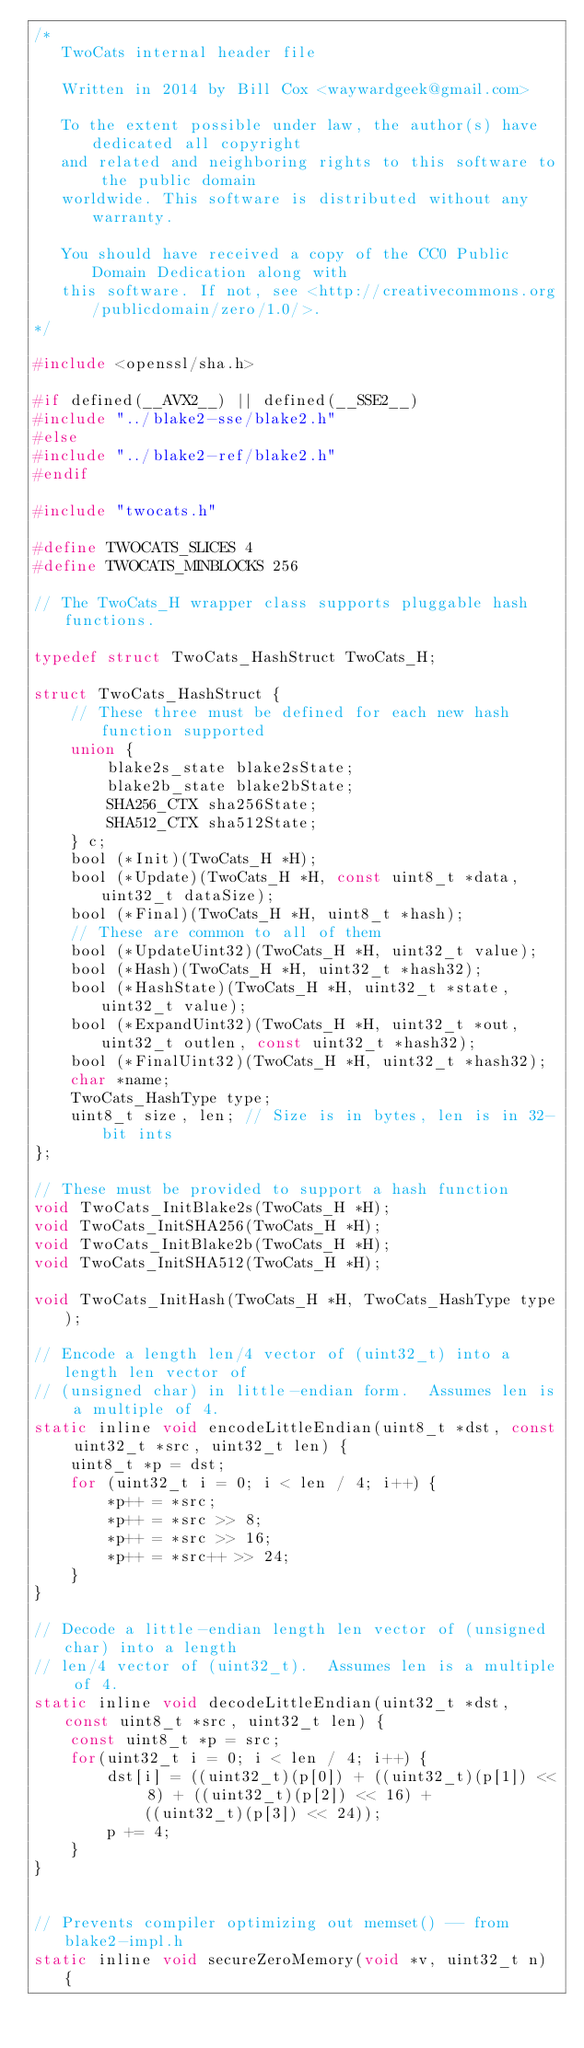<code> <loc_0><loc_0><loc_500><loc_500><_C_>/*
   TwoCats internal header file

   Written in 2014 by Bill Cox <waywardgeek@gmail.com>

   To the extent possible under law, the author(s) have dedicated all copyright
   and related and neighboring rights to this software to the public domain
   worldwide. This software is distributed without any warranty.

   You should have received a copy of the CC0 Public Domain Dedication along with
   this software. If not, see <http://creativecommons.org/publicdomain/zero/1.0/>.
*/

#include <openssl/sha.h>

#if defined(__AVX2__) || defined(__SSE2__)
#include "../blake2-sse/blake2.h"
#else
#include "../blake2-ref/blake2.h"
#endif

#include "twocats.h"

#define TWOCATS_SLICES 4
#define TWOCATS_MINBLOCKS 256

// The TwoCats_H wrapper class supports pluggable hash functions.

typedef struct TwoCats_HashStruct TwoCats_H;

struct TwoCats_HashStruct {
    // These three must be defined for each new hash function supported
    union {
        blake2s_state blake2sState;
        blake2b_state blake2bState;
        SHA256_CTX sha256State;
        SHA512_CTX sha512State;
    } c;
    bool (*Init)(TwoCats_H *H);
    bool (*Update)(TwoCats_H *H, const uint8_t *data, uint32_t dataSize);
    bool (*Final)(TwoCats_H *H, uint8_t *hash);
    // These are common to all of them
    bool (*UpdateUint32)(TwoCats_H *H, uint32_t value);
    bool (*Hash)(TwoCats_H *H, uint32_t *hash32);
    bool (*HashState)(TwoCats_H *H, uint32_t *state, uint32_t value);
    bool (*ExpandUint32)(TwoCats_H *H, uint32_t *out, uint32_t outlen, const uint32_t *hash32);
    bool (*FinalUint32)(TwoCats_H *H, uint32_t *hash32);
    char *name;
    TwoCats_HashType type;
    uint8_t size, len; // Size is in bytes, len is in 32-bit ints
};

// These must be provided to support a hash function
void TwoCats_InitBlake2s(TwoCats_H *H);
void TwoCats_InitSHA256(TwoCats_H *H);
void TwoCats_InitBlake2b(TwoCats_H *H);
void TwoCats_InitSHA512(TwoCats_H *H);

void TwoCats_InitHash(TwoCats_H *H, TwoCats_HashType type);

// Encode a length len/4 vector of (uint32_t) into a length len vector of
// (unsigned char) in little-endian form.  Assumes len is a multiple of 4.
static inline void encodeLittleEndian(uint8_t *dst, const uint32_t *src, uint32_t len) {
    uint8_t *p = dst;
    for (uint32_t i = 0; i < len / 4; i++) {
        *p++ = *src;
        *p++ = *src >> 8;
        *p++ = *src >> 16;
        *p++ = *src++ >> 24;
    }
}

// Decode a little-endian length len vector of (unsigned char) into a length
// len/4 vector of (uint32_t).  Assumes len is a multiple of 4.
static inline void decodeLittleEndian(uint32_t *dst, const uint8_t *src, uint32_t len) {
    const uint8_t *p = src;
    for(uint32_t i = 0; i < len / 4; i++) {
        dst[i] = ((uint32_t)(p[0]) + ((uint32_t)(p[1]) << 8) + ((uint32_t)(p[2]) << 16) +
            ((uint32_t)(p[3]) << 24));
        p += 4;
    }
}


// Prevents compiler optimizing out memset() -- from blake2-impl.h
static inline void secureZeroMemory(void *v, uint32_t n) {</code> 